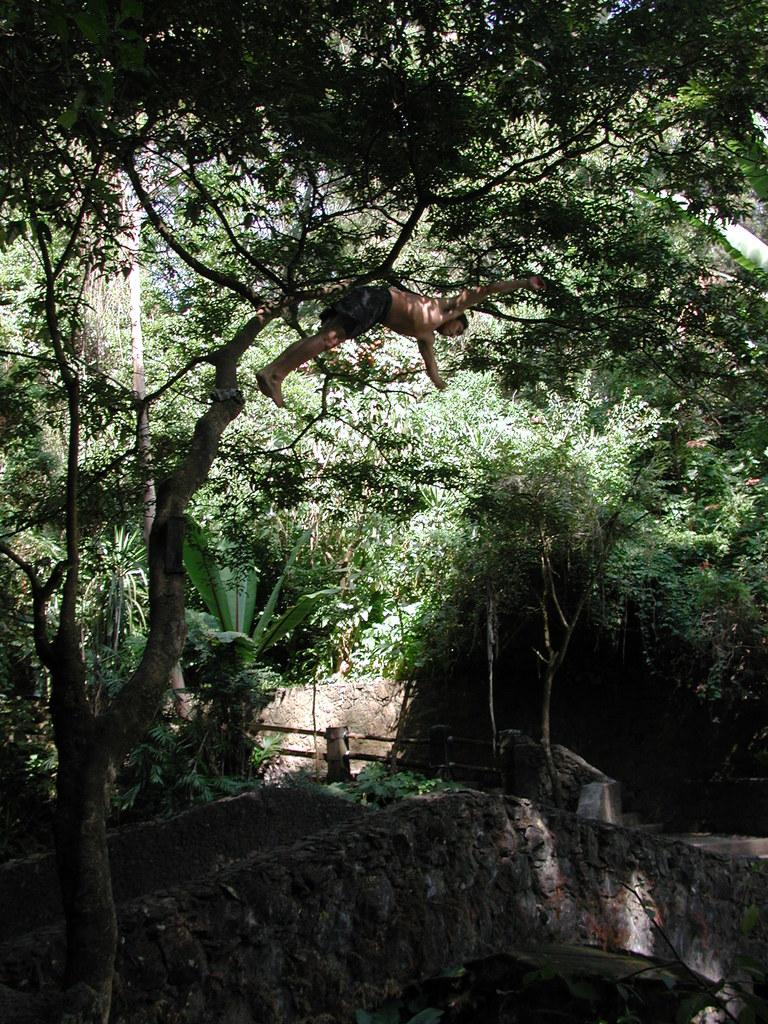What is the person in the image doing? The person is hanging on a tree in the image. What is located below the tree in the image? There is a bridge below the tree in the image. What can be seen in the image besides the tree and bridge? There is a fence, trees, plants, and a wall in the background of the image. What type of vacation is the person planning based on the image? There is no indication of a vacation in the image; it simply shows a person hanging on a tree with a bridge below. Can you tell me where the basin is located in the image? There is no basin present in the image. 